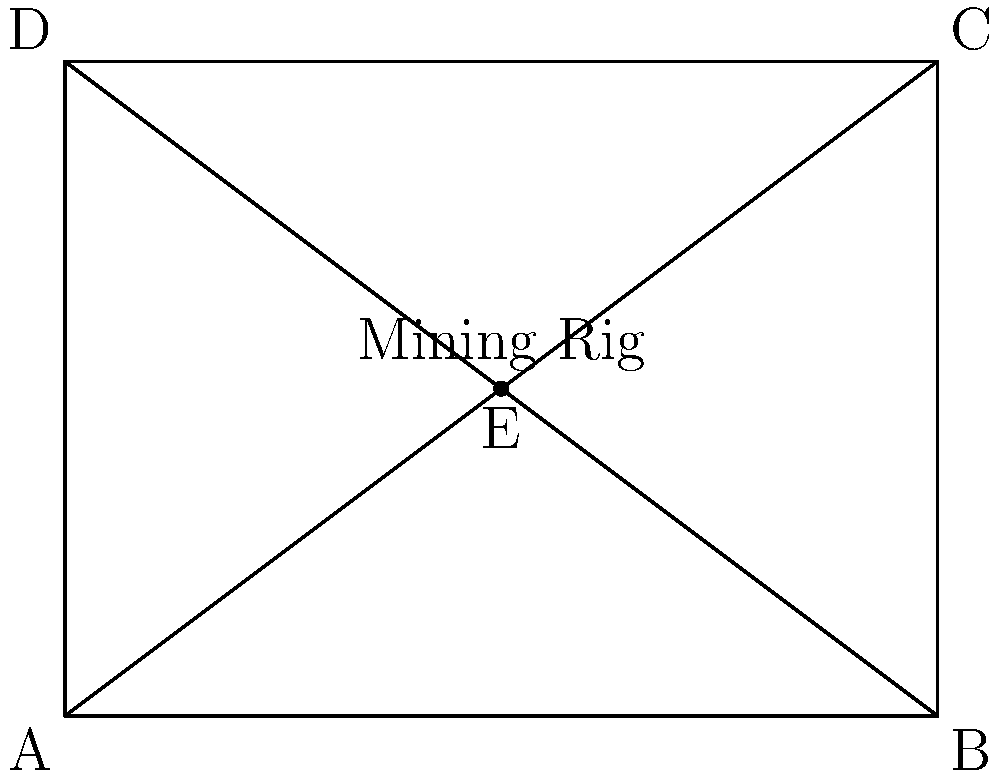A mining rig schematic is represented by the rectangle ABCD with diagonals AC and BD. Point E is the center of the rig. The rig undergoes two transformations:
1. A rotation of 90° clockwise around point E
2. A reflection across the line EC

What is the final position of point A after these transformations? Let's approach this step-by-step:

1. First, we rotate 90° clockwise around point E:
   - A (0,0) rotates to (3,0)
   - B (4,0) rotates to (3,3)
   - C (4,3) rotates to (1,3)
   - D (0,3) rotates to (1,0)

2. Now, we reflect across line EC:
   - The line EC becomes the axis of reflection
   - Point (3,0) reflects to (1,3)

3. Therefore, after both transformations:
   - A (0,0) → (3,0) → (1,3)

4. We can verify that (1,3) is indeed the final position of A:
   - It's the same as point C in the original figure
   - This makes sense geometrically, as the two transformations effectively move A to C's position

Thus, the final position of point A is the same as the original position of point C, which is (1,3) in our coordinate system.
Answer: $(1,3)$ 